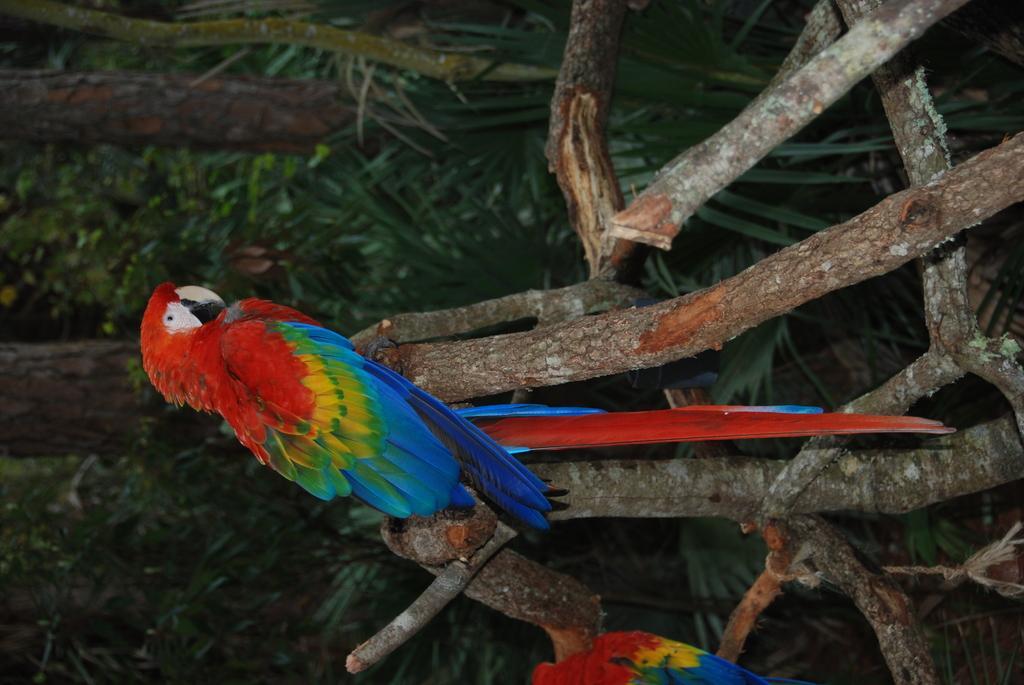Describe this image in one or two sentences. In this picture we can see grass, few birds and wooden sticks. 